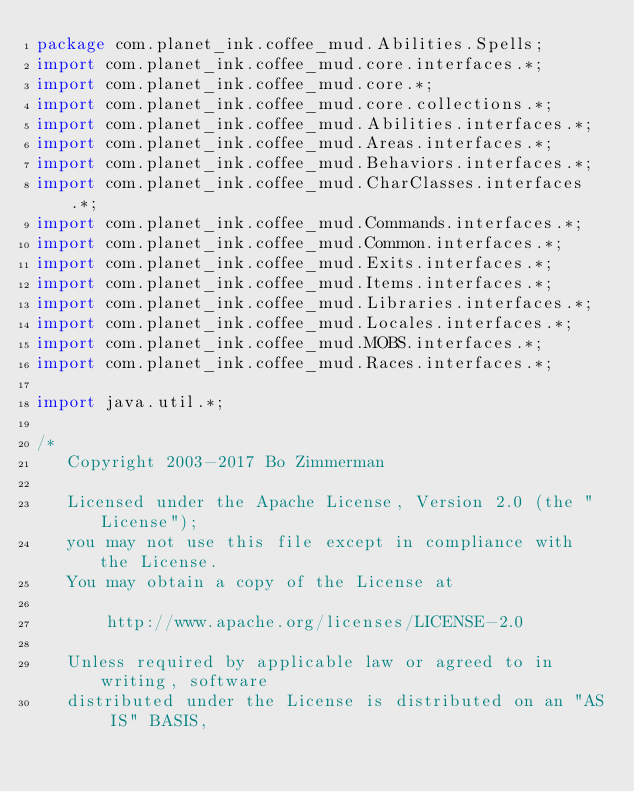<code> <loc_0><loc_0><loc_500><loc_500><_Java_>package com.planet_ink.coffee_mud.Abilities.Spells;
import com.planet_ink.coffee_mud.core.interfaces.*;
import com.planet_ink.coffee_mud.core.*;
import com.planet_ink.coffee_mud.core.collections.*;
import com.planet_ink.coffee_mud.Abilities.interfaces.*;
import com.planet_ink.coffee_mud.Areas.interfaces.*;
import com.planet_ink.coffee_mud.Behaviors.interfaces.*;
import com.planet_ink.coffee_mud.CharClasses.interfaces.*;
import com.planet_ink.coffee_mud.Commands.interfaces.*;
import com.planet_ink.coffee_mud.Common.interfaces.*;
import com.planet_ink.coffee_mud.Exits.interfaces.*;
import com.planet_ink.coffee_mud.Items.interfaces.*;
import com.planet_ink.coffee_mud.Libraries.interfaces.*;
import com.planet_ink.coffee_mud.Locales.interfaces.*;
import com.planet_ink.coffee_mud.MOBS.interfaces.*;
import com.planet_ink.coffee_mud.Races.interfaces.*;

import java.util.*;

/*
   Copyright 2003-2017 Bo Zimmerman

   Licensed under the Apache License, Version 2.0 (the "License");
   you may not use this file except in compliance with the License.
   You may obtain a copy of the License at

	   http://www.apache.org/licenses/LICENSE-2.0

   Unless required by applicable law or agreed to in writing, software
   distributed under the License is distributed on an "AS IS" BASIS,</code> 